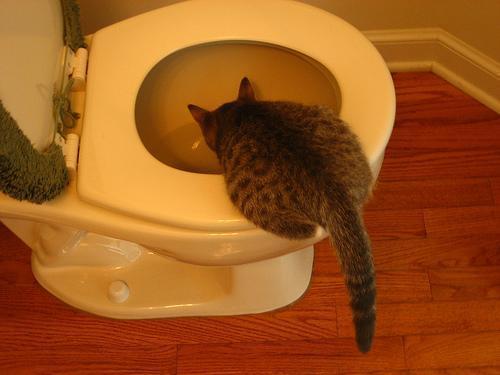How many cats are shown?
Give a very brief answer. 1. How many of the cat's ears are visible?
Give a very brief answer. 2. 